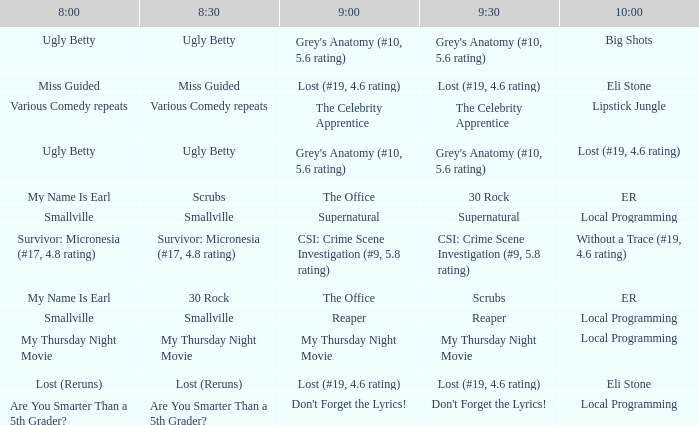What is at 8:00 when at 8:30 it is my thursday night movie? My Thursday Night Movie. 